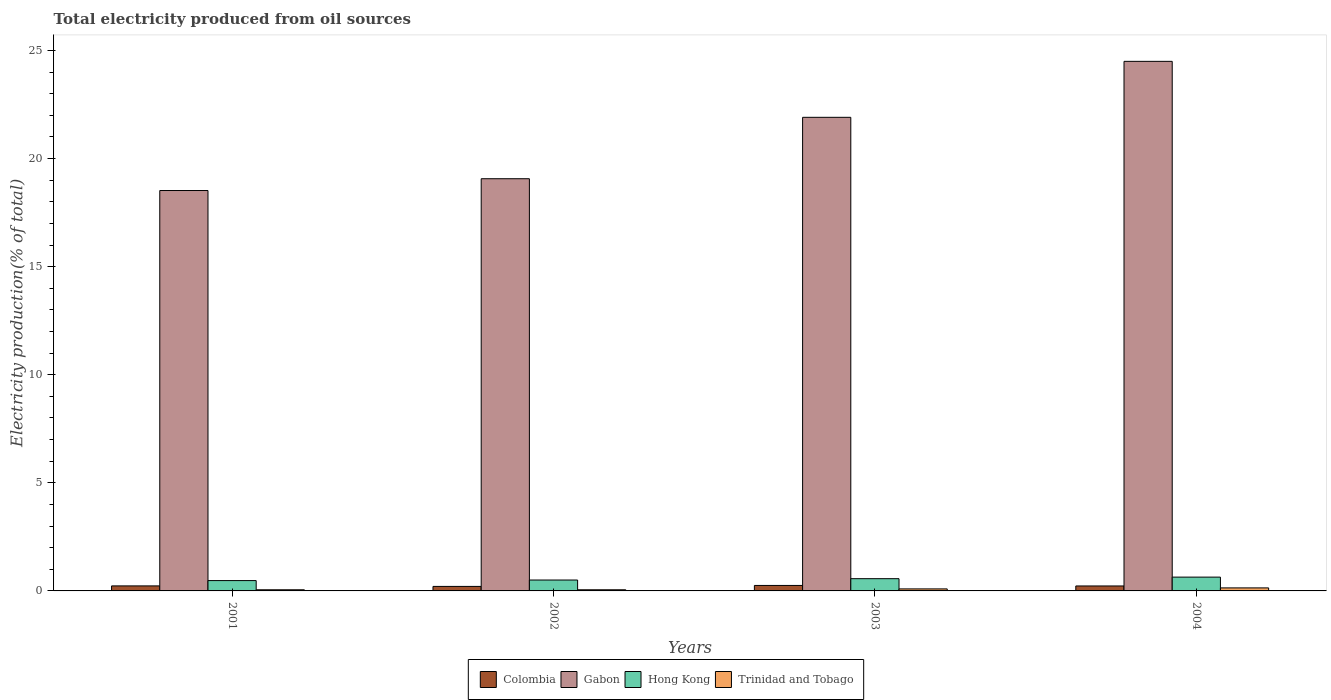How many different coloured bars are there?
Offer a terse response. 4. How many groups of bars are there?
Offer a very short reply. 4. Are the number of bars per tick equal to the number of legend labels?
Your answer should be very brief. Yes. Are the number of bars on each tick of the X-axis equal?
Offer a terse response. Yes. How many bars are there on the 3rd tick from the left?
Your answer should be very brief. 4. What is the total electricity produced in Colombia in 2001?
Provide a succinct answer. 0.23. Across all years, what is the maximum total electricity produced in Gabon?
Provide a succinct answer. 24.5. Across all years, what is the minimum total electricity produced in Colombia?
Keep it short and to the point. 0.21. What is the total total electricity produced in Gabon in the graph?
Your response must be concise. 83.99. What is the difference between the total electricity produced in Hong Kong in 2001 and that in 2002?
Your response must be concise. -0.03. What is the difference between the total electricity produced in Colombia in 2002 and the total electricity produced in Trinidad and Tobago in 2004?
Provide a short and direct response. 0.07. What is the average total electricity produced in Gabon per year?
Provide a succinct answer. 21. In the year 2003, what is the difference between the total electricity produced in Colombia and total electricity produced in Hong Kong?
Your response must be concise. -0.31. In how many years, is the total electricity produced in Colombia greater than 1 %?
Your response must be concise. 0. What is the ratio of the total electricity produced in Trinidad and Tobago in 2003 to that in 2004?
Your answer should be compact. 0.67. Is the total electricity produced in Hong Kong in 2002 less than that in 2004?
Offer a very short reply. Yes. Is the difference between the total electricity produced in Colombia in 2001 and 2004 greater than the difference between the total electricity produced in Hong Kong in 2001 and 2004?
Provide a succinct answer. Yes. What is the difference between the highest and the second highest total electricity produced in Gabon?
Offer a terse response. 2.59. What is the difference between the highest and the lowest total electricity produced in Gabon?
Give a very brief answer. 5.98. Is the sum of the total electricity produced in Trinidad and Tobago in 2001 and 2002 greater than the maximum total electricity produced in Hong Kong across all years?
Provide a succinct answer. No. Is it the case that in every year, the sum of the total electricity produced in Colombia and total electricity produced in Trinidad and Tobago is greater than the sum of total electricity produced in Gabon and total electricity produced in Hong Kong?
Give a very brief answer. No. What does the 2nd bar from the left in 2003 represents?
Make the answer very short. Gabon. What does the 3rd bar from the right in 2003 represents?
Provide a short and direct response. Gabon. Is it the case that in every year, the sum of the total electricity produced in Gabon and total electricity produced in Colombia is greater than the total electricity produced in Hong Kong?
Provide a short and direct response. Yes. How many years are there in the graph?
Provide a succinct answer. 4. Does the graph contain grids?
Your answer should be very brief. No. Where does the legend appear in the graph?
Your answer should be very brief. Bottom center. How are the legend labels stacked?
Make the answer very short. Horizontal. What is the title of the graph?
Provide a succinct answer. Total electricity produced from oil sources. What is the label or title of the Y-axis?
Provide a short and direct response. Electricity production(% of total). What is the Electricity production(% of total) in Colombia in 2001?
Your response must be concise. 0.23. What is the Electricity production(% of total) in Gabon in 2001?
Provide a short and direct response. 18.52. What is the Electricity production(% of total) in Hong Kong in 2001?
Keep it short and to the point. 0.48. What is the Electricity production(% of total) of Trinidad and Tobago in 2001?
Offer a terse response. 0.05. What is the Electricity production(% of total) of Colombia in 2002?
Offer a very short reply. 0.21. What is the Electricity production(% of total) in Gabon in 2002?
Provide a short and direct response. 19.07. What is the Electricity production(% of total) of Hong Kong in 2002?
Provide a succinct answer. 0.5. What is the Electricity production(% of total) in Trinidad and Tobago in 2002?
Provide a short and direct response. 0.05. What is the Electricity production(% of total) of Colombia in 2003?
Give a very brief answer. 0.25. What is the Electricity production(% of total) of Gabon in 2003?
Your answer should be very brief. 21.91. What is the Electricity production(% of total) in Hong Kong in 2003?
Keep it short and to the point. 0.57. What is the Electricity production(% of total) of Trinidad and Tobago in 2003?
Keep it short and to the point. 0.09. What is the Electricity production(% of total) of Colombia in 2004?
Offer a terse response. 0.23. What is the Electricity production(% of total) in Gabon in 2004?
Offer a terse response. 24.5. What is the Electricity production(% of total) in Hong Kong in 2004?
Provide a succinct answer. 0.64. What is the Electricity production(% of total) in Trinidad and Tobago in 2004?
Offer a terse response. 0.14. Across all years, what is the maximum Electricity production(% of total) of Colombia?
Provide a succinct answer. 0.25. Across all years, what is the maximum Electricity production(% of total) of Gabon?
Offer a terse response. 24.5. Across all years, what is the maximum Electricity production(% of total) of Hong Kong?
Make the answer very short. 0.64. Across all years, what is the maximum Electricity production(% of total) of Trinidad and Tobago?
Your response must be concise. 0.14. Across all years, what is the minimum Electricity production(% of total) in Colombia?
Your answer should be compact. 0.21. Across all years, what is the minimum Electricity production(% of total) of Gabon?
Keep it short and to the point. 18.52. Across all years, what is the minimum Electricity production(% of total) of Hong Kong?
Your response must be concise. 0.48. Across all years, what is the minimum Electricity production(% of total) in Trinidad and Tobago?
Offer a very short reply. 0.05. What is the total Electricity production(% of total) of Colombia in the graph?
Offer a very short reply. 0.92. What is the total Electricity production(% of total) of Gabon in the graph?
Your answer should be compact. 83.99. What is the total Electricity production(% of total) in Hong Kong in the graph?
Offer a terse response. 2.19. What is the total Electricity production(% of total) in Trinidad and Tobago in the graph?
Provide a succinct answer. 0.34. What is the difference between the Electricity production(% of total) in Colombia in 2001 and that in 2002?
Make the answer very short. 0.02. What is the difference between the Electricity production(% of total) in Gabon in 2001 and that in 2002?
Keep it short and to the point. -0.55. What is the difference between the Electricity production(% of total) in Hong Kong in 2001 and that in 2002?
Your answer should be very brief. -0.03. What is the difference between the Electricity production(% of total) in Colombia in 2001 and that in 2003?
Provide a short and direct response. -0.02. What is the difference between the Electricity production(% of total) of Gabon in 2001 and that in 2003?
Offer a terse response. -3.39. What is the difference between the Electricity production(% of total) of Hong Kong in 2001 and that in 2003?
Your answer should be compact. -0.09. What is the difference between the Electricity production(% of total) of Trinidad and Tobago in 2001 and that in 2003?
Provide a short and direct response. -0.04. What is the difference between the Electricity production(% of total) in Colombia in 2001 and that in 2004?
Give a very brief answer. 0. What is the difference between the Electricity production(% of total) of Gabon in 2001 and that in 2004?
Offer a terse response. -5.98. What is the difference between the Electricity production(% of total) of Hong Kong in 2001 and that in 2004?
Ensure brevity in your answer.  -0.16. What is the difference between the Electricity production(% of total) of Trinidad and Tobago in 2001 and that in 2004?
Provide a short and direct response. -0.09. What is the difference between the Electricity production(% of total) in Colombia in 2002 and that in 2003?
Offer a terse response. -0.04. What is the difference between the Electricity production(% of total) of Gabon in 2002 and that in 2003?
Make the answer very short. -2.84. What is the difference between the Electricity production(% of total) of Hong Kong in 2002 and that in 2003?
Your answer should be compact. -0.06. What is the difference between the Electricity production(% of total) of Trinidad and Tobago in 2002 and that in 2003?
Provide a short and direct response. -0.04. What is the difference between the Electricity production(% of total) of Colombia in 2002 and that in 2004?
Offer a very short reply. -0.02. What is the difference between the Electricity production(% of total) in Gabon in 2002 and that in 2004?
Provide a short and direct response. -5.43. What is the difference between the Electricity production(% of total) of Hong Kong in 2002 and that in 2004?
Make the answer very short. -0.13. What is the difference between the Electricity production(% of total) in Trinidad and Tobago in 2002 and that in 2004?
Keep it short and to the point. -0.09. What is the difference between the Electricity production(% of total) in Colombia in 2003 and that in 2004?
Make the answer very short. 0.02. What is the difference between the Electricity production(% of total) in Gabon in 2003 and that in 2004?
Ensure brevity in your answer.  -2.59. What is the difference between the Electricity production(% of total) in Hong Kong in 2003 and that in 2004?
Provide a short and direct response. -0.07. What is the difference between the Electricity production(% of total) in Trinidad and Tobago in 2003 and that in 2004?
Provide a short and direct response. -0.05. What is the difference between the Electricity production(% of total) of Colombia in 2001 and the Electricity production(% of total) of Gabon in 2002?
Make the answer very short. -18.83. What is the difference between the Electricity production(% of total) in Colombia in 2001 and the Electricity production(% of total) in Hong Kong in 2002?
Provide a succinct answer. -0.27. What is the difference between the Electricity production(% of total) of Colombia in 2001 and the Electricity production(% of total) of Trinidad and Tobago in 2002?
Keep it short and to the point. 0.18. What is the difference between the Electricity production(% of total) of Gabon in 2001 and the Electricity production(% of total) of Hong Kong in 2002?
Ensure brevity in your answer.  18.02. What is the difference between the Electricity production(% of total) of Gabon in 2001 and the Electricity production(% of total) of Trinidad and Tobago in 2002?
Offer a very short reply. 18.47. What is the difference between the Electricity production(% of total) of Hong Kong in 2001 and the Electricity production(% of total) of Trinidad and Tobago in 2002?
Give a very brief answer. 0.42. What is the difference between the Electricity production(% of total) of Colombia in 2001 and the Electricity production(% of total) of Gabon in 2003?
Give a very brief answer. -21.68. What is the difference between the Electricity production(% of total) of Colombia in 2001 and the Electricity production(% of total) of Hong Kong in 2003?
Offer a very short reply. -0.33. What is the difference between the Electricity production(% of total) of Colombia in 2001 and the Electricity production(% of total) of Trinidad and Tobago in 2003?
Your answer should be compact. 0.14. What is the difference between the Electricity production(% of total) of Gabon in 2001 and the Electricity production(% of total) of Hong Kong in 2003?
Offer a terse response. 17.96. What is the difference between the Electricity production(% of total) of Gabon in 2001 and the Electricity production(% of total) of Trinidad and Tobago in 2003?
Ensure brevity in your answer.  18.43. What is the difference between the Electricity production(% of total) in Hong Kong in 2001 and the Electricity production(% of total) in Trinidad and Tobago in 2003?
Offer a terse response. 0.38. What is the difference between the Electricity production(% of total) of Colombia in 2001 and the Electricity production(% of total) of Gabon in 2004?
Offer a terse response. -24.26. What is the difference between the Electricity production(% of total) in Colombia in 2001 and the Electricity production(% of total) in Hong Kong in 2004?
Provide a short and direct response. -0.41. What is the difference between the Electricity production(% of total) in Colombia in 2001 and the Electricity production(% of total) in Trinidad and Tobago in 2004?
Keep it short and to the point. 0.09. What is the difference between the Electricity production(% of total) of Gabon in 2001 and the Electricity production(% of total) of Hong Kong in 2004?
Ensure brevity in your answer.  17.88. What is the difference between the Electricity production(% of total) in Gabon in 2001 and the Electricity production(% of total) in Trinidad and Tobago in 2004?
Provide a short and direct response. 18.38. What is the difference between the Electricity production(% of total) of Hong Kong in 2001 and the Electricity production(% of total) of Trinidad and Tobago in 2004?
Give a very brief answer. 0.34. What is the difference between the Electricity production(% of total) in Colombia in 2002 and the Electricity production(% of total) in Gabon in 2003?
Give a very brief answer. -21.7. What is the difference between the Electricity production(% of total) in Colombia in 2002 and the Electricity production(% of total) in Hong Kong in 2003?
Your response must be concise. -0.36. What is the difference between the Electricity production(% of total) of Colombia in 2002 and the Electricity production(% of total) of Trinidad and Tobago in 2003?
Provide a succinct answer. 0.12. What is the difference between the Electricity production(% of total) of Gabon in 2002 and the Electricity production(% of total) of Hong Kong in 2003?
Offer a very short reply. 18.5. What is the difference between the Electricity production(% of total) of Gabon in 2002 and the Electricity production(% of total) of Trinidad and Tobago in 2003?
Make the answer very short. 18.97. What is the difference between the Electricity production(% of total) in Hong Kong in 2002 and the Electricity production(% of total) in Trinidad and Tobago in 2003?
Make the answer very short. 0.41. What is the difference between the Electricity production(% of total) of Colombia in 2002 and the Electricity production(% of total) of Gabon in 2004?
Your answer should be compact. -24.29. What is the difference between the Electricity production(% of total) of Colombia in 2002 and the Electricity production(% of total) of Hong Kong in 2004?
Your response must be concise. -0.43. What is the difference between the Electricity production(% of total) of Colombia in 2002 and the Electricity production(% of total) of Trinidad and Tobago in 2004?
Offer a very short reply. 0.07. What is the difference between the Electricity production(% of total) of Gabon in 2002 and the Electricity production(% of total) of Hong Kong in 2004?
Offer a terse response. 18.43. What is the difference between the Electricity production(% of total) in Gabon in 2002 and the Electricity production(% of total) in Trinidad and Tobago in 2004?
Make the answer very short. 18.93. What is the difference between the Electricity production(% of total) in Hong Kong in 2002 and the Electricity production(% of total) in Trinidad and Tobago in 2004?
Ensure brevity in your answer.  0.36. What is the difference between the Electricity production(% of total) in Colombia in 2003 and the Electricity production(% of total) in Gabon in 2004?
Make the answer very short. -24.24. What is the difference between the Electricity production(% of total) of Colombia in 2003 and the Electricity production(% of total) of Hong Kong in 2004?
Make the answer very short. -0.38. What is the difference between the Electricity production(% of total) of Colombia in 2003 and the Electricity production(% of total) of Trinidad and Tobago in 2004?
Ensure brevity in your answer.  0.11. What is the difference between the Electricity production(% of total) in Gabon in 2003 and the Electricity production(% of total) in Hong Kong in 2004?
Your answer should be very brief. 21.27. What is the difference between the Electricity production(% of total) in Gabon in 2003 and the Electricity production(% of total) in Trinidad and Tobago in 2004?
Keep it short and to the point. 21.77. What is the difference between the Electricity production(% of total) in Hong Kong in 2003 and the Electricity production(% of total) in Trinidad and Tobago in 2004?
Provide a succinct answer. 0.43. What is the average Electricity production(% of total) in Colombia per year?
Give a very brief answer. 0.23. What is the average Electricity production(% of total) in Gabon per year?
Give a very brief answer. 21. What is the average Electricity production(% of total) of Hong Kong per year?
Provide a succinct answer. 0.55. What is the average Electricity production(% of total) in Trinidad and Tobago per year?
Your answer should be very brief. 0.08. In the year 2001, what is the difference between the Electricity production(% of total) in Colombia and Electricity production(% of total) in Gabon?
Offer a very short reply. -18.29. In the year 2001, what is the difference between the Electricity production(% of total) of Colombia and Electricity production(% of total) of Hong Kong?
Offer a very short reply. -0.25. In the year 2001, what is the difference between the Electricity production(% of total) in Colombia and Electricity production(% of total) in Trinidad and Tobago?
Your answer should be compact. 0.18. In the year 2001, what is the difference between the Electricity production(% of total) of Gabon and Electricity production(% of total) of Hong Kong?
Provide a short and direct response. 18.04. In the year 2001, what is the difference between the Electricity production(% of total) of Gabon and Electricity production(% of total) of Trinidad and Tobago?
Offer a terse response. 18.47. In the year 2001, what is the difference between the Electricity production(% of total) in Hong Kong and Electricity production(% of total) in Trinidad and Tobago?
Provide a short and direct response. 0.42. In the year 2002, what is the difference between the Electricity production(% of total) of Colombia and Electricity production(% of total) of Gabon?
Provide a short and direct response. -18.86. In the year 2002, what is the difference between the Electricity production(% of total) in Colombia and Electricity production(% of total) in Hong Kong?
Your answer should be compact. -0.3. In the year 2002, what is the difference between the Electricity production(% of total) in Colombia and Electricity production(% of total) in Trinidad and Tobago?
Your answer should be compact. 0.16. In the year 2002, what is the difference between the Electricity production(% of total) in Gabon and Electricity production(% of total) in Hong Kong?
Ensure brevity in your answer.  18.56. In the year 2002, what is the difference between the Electricity production(% of total) in Gabon and Electricity production(% of total) in Trinidad and Tobago?
Make the answer very short. 19.01. In the year 2002, what is the difference between the Electricity production(% of total) in Hong Kong and Electricity production(% of total) in Trinidad and Tobago?
Make the answer very short. 0.45. In the year 2003, what is the difference between the Electricity production(% of total) of Colombia and Electricity production(% of total) of Gabon?
Your response must be concise. -21.65. In the year 2003, what is the difference between the Electricity production(% of total) of Colombia and Electricity production(% of total) of Hong Kong?
Offer a terse response. -0.31. In the year 2003, what is the difference between the Electricity production(% of total) in Colombia and Electricity production(% of total) in Trinidad and Tobago?
Provide a short and direct response. 0.16. In the year 2003, what is the difference between the Electricity production(% of total) in Gabon and Electricity production(% of total) in Hong Kong?
Ensure brevity in your answer.  21.34. In the year 2003, what is the difference between the Electricity production(% of total) of Gabon and Electricity production(% of total) of Trinidad and Tobago?
Provide a succinct answer. 21.81. In the year 2003, what is the difference between the Electricity production(% of total) in Hong Kong and Electricity production(% of total) in Trinidad and Tobago?
Ensure brevity in your answer.  0.47. In the year 2004, what is the difference between the Electricity production(% of total) in Colombia and Electricity production(% of total) in Gabon?
Ensure brevity in your answer.  -24.27. In the year 2004, what is the difference between the Electricity production(% of total) of Colombia and Electricity production(% of total) of Hong Kong?
Your answer should be compact. -0.41. In the year 2004, what is the difference between the Electricity production(% of total) of Colombia and Electricity production(% of total) of Trinidad and Tobago?
Give a very brief answer. 0.09. In the year 2004, what is the difference between the Electricity production(% of total) in Gabon and Electricity production(% of total) in Hong Kong?
Offer a very short reply. 23.86. In the year 2004, what is the difference between the Electricity production(% of total) in Gabon and Electricity production(% of total) in Trinidad and Tobago?
Offer a terse response. 24.36. In the year 2004, what is the difference between the Electricity production(% of total) of Hong Kong and Electricity production(% of total) of Trinidad and Tobago?
Make the answer very short. 0.5. What is the ratio of the Electricity production(% of total) of Colombia in 2001 to that in 2002?
Your answer should be compact. 1.11. What is the ratio of the Electricity production(% of total) of Gabon in 2001 to that in 2002?
Provide a short and direct response. 0.97. What is the ratio of the Electricity production(% of total) of Hong Kong in 2001 to that in 2002?
Provide a succinct answer. 0.95. What is the ratio of the Electricity production(% of total) in Trinidad and Tobago in 2001 to that in 2002?
Ensure brevity in your answer.  1. What is the ratio of the Electricity production(% of total) of Colombia in 2001 to that in 2003?
Ensure brevity in your answer.  0.92. What is the ratio of the Electricity production(% of total) of Gabon in 2001 to that in 2003?
Ensure brevity in your answer.  0.85. What is the ratio of the Electricity production(% of total) of Hong Kong in 2001 to that in 2003?
Offer a terse response. 0.84. What is the ratio of the Electricity production(% of total) of Trinidad and Tobago in 2001 to that in 2003?
Make the answer very short. 0.57. What is the ratio of the Electricity production(% of total) of Colombia in 2001 to that in 2004?
Offer a terse response. 1.01. What is the ratio of the Electricity production(% of total) of Gabon in 2001 to that in 2004?
Your response must be concise. 0.76. What is the ratio of the Electricity production(% of total) of Hong Kong in 2001 to that in 2004?
Ensure brevity in your answer.  0.75. What is the ratio of the Electricity production(% of total) in Trinidad and Tobago in 2001 to that in 2004?
Provide a short and direct response. 0.38. What is the ratio of the Electricity production(% of total) of Colombia in 2002 to that in 2003?
Offer a very short reply. 0.82. What is the ratio of the Electricity production(% of total) in Gabon in 2002 to that in 2003?
Offer a terse response. 0.87. What is the ratio of the Electricity production(% of total) of Hong Kong in 2002 to that in 2003?
Your answer should be very brief. 0.89. What is the ratio of the Electricity production(% of total) of Trinidad and Tobago in 2002 to that in 2003?
Make the answer very short. 0.57. What is the ratio of the Electricity production(% of total) of Colombia in 2002 to that in 2004?
Your answer should be compact. 0.91. What is the ratio of the Electricity production(% of total) in Gabon in 2002 to that in 2004?
Give a very brief answer. 0.78. What is the ratio of the Electricity production(% of total) in Hong Kong in 2002 to that in 2004?
Your answer should be very brief. 0.79. What is the ratio of the Electricity production(% of total) of Trinidad and Tobago in 2002 to that in 2004?
Offer a very short reply. 0.38. What is the ratio of the Electricity production(% of total) in Colombia in 2003 to that in 2004?
Make the answer very short. 1.11. What is the ratio of the Electricity production(% of total) in Gabon in 2003 to that in 2004?
Your answer should be very brief. 0.89. What is the ratio of the Electricity production(% of total) in Hong Kong in 2003 to that in 2004?
Provide a short and direct response. 0.89. What is the ratio of the Electricity production(% of total) in Trinidad and Tobago in 2003 to that in 2004?
Provide a short and direct response. 0.67. What is the difference between the highest and the second highest Electricity production(% of total) in Colombia?
Ensure brevity in your answer.  0.02. What is the difference between the highest and the second highest Electricity production(% of total) in Gabon?
Provide a succinct answer. 2.59. What is the difference between the highest and the second highest Electricity production(% of total) in Hong Kong?
Provide a short and direct response. 0.07. What is the difference between the highest and the second highest Electricity production(% of total) of Trinidad and Tobago?
Offer a very short reply. 0.05. What is the difference between the highest and the lowest Electricity production(% of total) of Colombia?
Provide a short and direct response. 0.04. What is the difference between the highest and the lowest Electricity production(% of total) of Gabon?
Offer a very short reply. 5.98. What is the difference between the highest and the lowest Electricity production(% of total) in Hong Kong?
Your answer should be compact. 0.16. What is the difference between the highest and the lowest Electricity production(% of total) in Trinidad and Tobago?
Give a very brief answer. 0.09. 